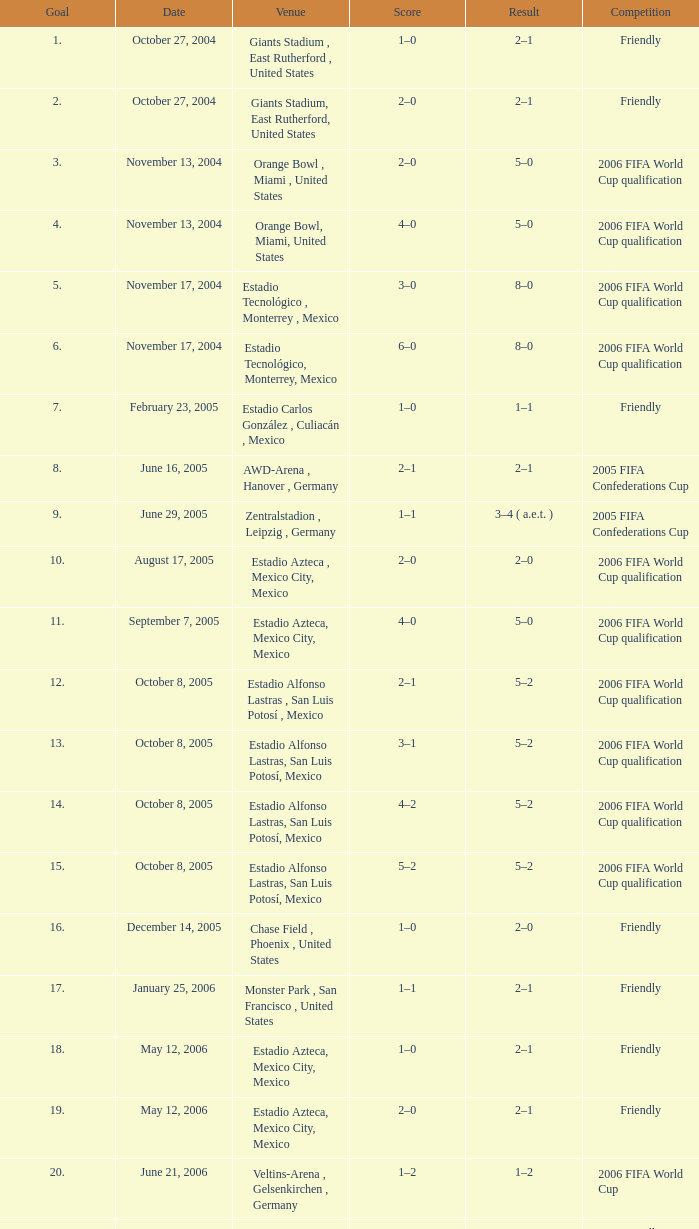Which competitive event occurs at estadio alfonso lastras, san luis potosí, mexico, and possesses a goal surpassing 15? Friendly. 